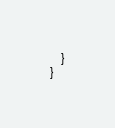<code> <loc_0><loc_0><loc_500><loc_500><_Java_>    }
}
</code> 